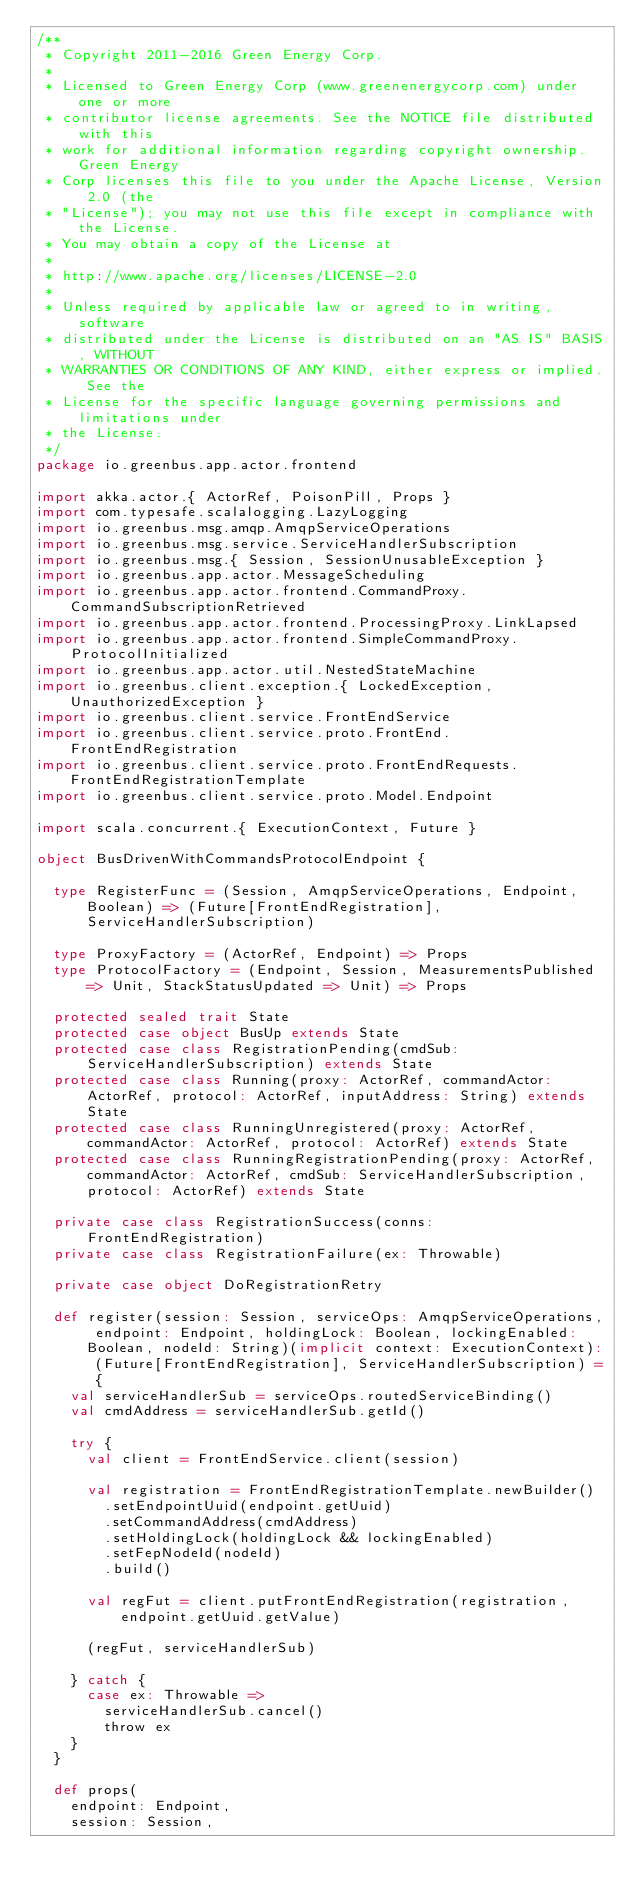Convert code to text. <code><loc_0><loc_0><loc_500><loc_500><_Scala_>/**
 * Copyright 2011-2016 Green Energy Corp.
 *
 * Licensed to Green Energy Corp (www.greenenergycorp.com) under one or more
 * contributor license agreements. See the NOTICE file distributed with this
 * work for additional information regarding copyright ownership. Green Energy
 * Corp licenses this file to you under the Apache License, Version 2.0 (the
 * "License"); you may not use this file except in compliance with the License.
 * You may obtain a copy of the License at
 *
 * http://www.apache.org/licenses/LICENSE-2.0
 *
 * Unless required by applicable law or agreed to in writing, software
 * distributed under the License is distributed on an "AS IS" BASIS, WITHOUT
 * WARRANTIES OR CONDITIONS OF ANY KIND, either express or implied. See the
 * License for the specific language governing permissions and limitations under
 * the License.
 */
package io.greenbus.app.actor.frontend

import akka.actor.{ ActorRef, PoisonPill, Props }
import com.typesafe.scalalogging.LazyLogging
import io.greenbus.msg.amqp.AmqpServiceOperations
import io.greenbus.msg.service.ServiceHandlerSubscription
import io.greenbus.msg.{ Session, SessionUnusableException }
import io.greenbus.app.actor.MessageScheduling
import io.greenbus.app.actor.frontend.CommandProxy.CommandSubscriptionRetrieved
import io.greenbus.app.actor.frontend.ProcessingProxy.LinkLapsed
import io.greenbus.app.actor.frontend.SimpleCommandProxy.ProtocolInitialized
import io.greenbus.app.actor.util.NestedStateMachine
import io.greenbus.client.exception.{ LockedException, UnauthorizedException }
import io.greenbus.client.service.FrontEndService
import io.greenbus.client.service.proto.FrontEnd.FrontEndRegistration
import io.greenbus.client.service.proto.FrontEndRequests.FrontEndRegistrationTemplate
import io.greenbus.client.service.proto.Model.Endpoint

import scala.concurrent.{ ExecutionContext, Future }

object BusDrivenWithCommandsProtocolEndpoint {

  type RegisterFunc = (Session, AmqpServiceOperations, Endpoint, Boolean) => (Future[FrontEndRegistration], ServiceHandlerSubscription)

  type ProxyFactory = (ActorRef, Endpoint) => Props
  type ProtocolFactory = (Endpoint, Session, MeasurementsPublished => Unit, StackStatusUpdated => Unit) => Props

  protected sealed trait State
  protected case object BusUp extends State
  protected case class RegistrationPending(cmdSub: ServiceHandlerSubscription) extends State
  protected case class Running(proxy: ActorRef, commandActor: ActorRef, protocol: ActorRef, inputAddress: String) extends State
  protected case class RunningUnregistered(proxy: ActorRef, commandActor: ActorRef, protocol: ActorRef) extends State
  protected case class RunningRegistrationPending(proxy: ActorRef, commandActor: ActorRef, cmdSub: ServiceHandlerSubscription, protocol: ActorRef) extends State

  private case class RegistrationSuccess(conns: FrontEndRegistration)
  private case class RegistrationFailure(ex: Throwable)

  private case object DoRegistrationRetry

  def register(session: Session, serviceOps: AmqpServiceOperations, endpoint: Endpoint, holdingLock: Boolean, lockingEnabled: Boolean, nodeId: String)(implicit context: ExecutionContext): (Future[FrontEndRegistration], ServiceHandlerSubscription) = {
    val serviceHandlerSub = serviceOps.routedServiceBinding()
    val cmdAddress = serviceHandlerSub.getId()

    try {
      val client = FrontEndService.client(session)

      val registration = FrontEndRegistrationTemplate.newBuilder()
        .setEndpointUuid(endpoint.getUuid)
        .setCommandAddress(cmdAddress)
        .setHoldingLock(holdingLock && lockingEnabled)
        .setFepNodeId(nodeId)
        .build()

      val regFut = client.putFrontEndRegistration(registration, endpoint.getUuid.getValue)

      (regFut, serviceHandlerSub)

    } catch {
      case ex: Throwable =>
        serviceHandlerSub.cancel()
        throw ex
    }
  }

  def props(
    endpoint: Endpoint,
    session: Session,</code> 